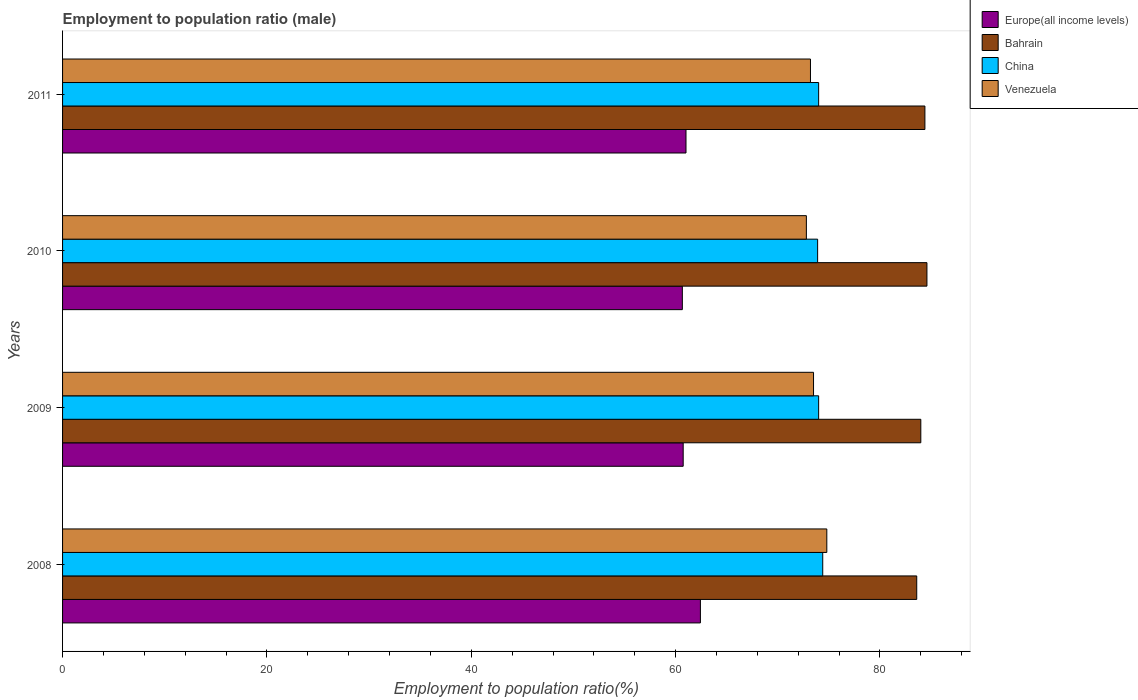Are the number of bars per tick equal to the number of legend labels?
Offer a very short reply. Yes. Are the number of bars on each tick of the Y-axis equal?
Offer a terse response. Yes. How many bars are there on the 4th tick from the top?
Provide a succinct answer. 4. How many bars are there on the 2nd tick from the bottom?
Provide a succinct answer. 4. In how many cases, is the number of bars for a given year not equal to the number of legend labels?
Provide a succinct answer. 0. What is the employment to population ratio in Europe(all income levels) in 2010?
Provide a succinct answer. 60.66. Across all years, what is the maximum employment to population ratio in China?
Provide a succinct answer. 74.4. Across all years, what is the minimum employment to population ratio in Europe(all income levels)?
Keep it short and to the point. 60.66. In which year was the employment to population ratio in Europe(all income levels) minimum?
Offer a terse response. 2010. What is the total employment to population ratio in Europe(all income levels) in the graph?
Your answer should be compact. 244.85. What is the difference between the employment to population ratio in China in 2009 and that in 2010?
Offer a terse response. 0.1. What is the difference between the employment to population ratio in Venezuela in 2010 and the employment to population ratio in Bahrain in 2008?
Give a very brief answer. -10.8. What is the average employment to population ratio in Europe(all income levels) per year?
Ensure brevity in your answer.  61.21. In the year 2010, what is the difference between the employment to population ratio in Venezuela and employment to population ratio in Europe(all income levels)?
Provide a succinct answer. 12.14. In how many years, is the employment to population ratio in Venezuela greater than 20 %?
Make the answer very short. 4. What is the ratio of the employment to population ratio in Venezuela in 2008 to that in 2009?
Offer a very short reply. 1.02. Is the difference between the employment to population ratio in Venezuela in 2008 and 2010 greater than the difference between the employment to population ratio in Europe(all income levels) in 2008 and 2010?
Provide a short and direct response. Yes. What is the difference between the highest and the second highest employment to population ratio in Bahrain?
Give a very brief answer. 0.2. What is the difference between the highest and the lowest employment to population ratio in Bahrain?
Make the answer very short. 1. Is it the case that in every year, the sum of the employment to population ratio in China and employment to population ratio in Venezuela is greater than the sum of employment to population ratio in Europe(all income levels) and employment to population ratio in Bahrain?
Provide a short and direct response. Yes. What does the 1st bar from the top in 2009 represents?
Your response must be concise. Venezuela. What does the 1st bar from the bottom in 2009 represents?
Your response must be concise. Europe(all income levels). How many bars are there?
Keep it short and to the point. 16. What is the difference between two consecutive major ticks on the X-axis?
Keep it short and to the point. 20. Does the graph contain any zero values?
Ensure brevity in your answer.  No. Does the graph contain grids?
Provide a short and direct response. No. How many legend labels are there?
Provide a short and direct response. 4. What is the title of the graph?
Provide a short and direct response. Employment to population ratio (male). Does "Angola" appear as one of the legend labels in the graph?
Your answer should be compact. No. What is the label or title of the X-axis?
Your response must be concise. Employment to population ratio(%). What is the Employment to population ratio(%) of Europe(all income levels) in 2008?
Provide a succinct answer. 62.43. What is the Employment to population ratio(%) in Bahrain in 2008?
Give a very brief answer. 83.6. What is the Employment to population ratio(%) of China in 2008?
Give a very brief answer. 74.4. What is the Employment to population ratio(%) of Venezuela in 2008?
Give a very brief answer. 74.8. What is the Employment to population ratio(%) in Europe(all income levels) in 2009?
Provide a short and direct response. 60.74. What is the Employment to population ratio(%) of Venezuela in 2009?
Your answer should be very brief. 73.5. What is the Employment to population ratio(%) of Europe(all income levels) in 2010?
Provide a succinct answer. 60.66. What is the Employment to population ratio(%) of Bahrain in 2010?
Provide a succinct answer. 84.6. What is the Employment to population ratio(%) in China in 2010?
Provide a short and direct response. 73.9. What is the Employment to population ratio(%) of Venezuela in 2010?
Keep it short and to the point. 72.8. What is the Employment to population ratio(%) in Europe(all income levels) in 2011?
Provide a succinct answer. 61.02. What is the Employment to population ratio(%) of Bahrain in 2011?
Give a very brief answer. 84.4. What is the Employment to population ratio(%) in Venezuela in 2011?
Your response must be concise. 73.2. Across all years, what is the maximum Employment to population ratio(%) of Europe(all income levels)?
Your answer should be compact. 62.43. Across all years, what is the maximum Employment to population ratio(%) in Bahrain?
Ensure brevity in your answer.  84.6. Across all years, what is the maximum Employment to population ratio(%) in China?
Offer a terse response. 74.4. Across all years, what is the maximum Employment to population ratio(%) of Venezuela?
Provide a succinct answer. 74.8. Across all years, what is the minimum Employment to population ratio(%) in Europe(all income levels)?
Provide a short and direct response. 60.66. Across all years, what is the minimum Employment to population ratio(%) of Bahrain?
Your answer should be very brief. 83.6. Across all years, what is the minimum Employment to population ratio(%) of China?
Give a very brief answer. 73.9. Across all years, what is the minimum Employment to population ratio(%) of Venezuela?
Provide a succinct answer. 72.8. What is the total Employment to population ratio(%) of Europe(all income levels) in the graph?
Offer a terse response. 244.85. What is the total Employment to population ratio(%) of Bahrain in the graph?
Ensure brevity in your answer.  336.6. What is the total Employment to population ratio(%) of China in the graph?
Ensure brevity in your answer.  296.3. What is the total Employment to population ratio(%) of Venezuela in the graph?
Offer a terse response. 294.3. What is the difference between the Employment to population ratio(%) of Europe(all income levels) in 2008 and that in 2009?
Ensure brevity in your answer.  1.69. What is the difference between the Employment to population ratio(%) in Bahrain in 2008 and that in 2009?
Provide a succinct answer. -0.4. What is the difference between the Employment to population ratio(%) in Europe(all income levels) in 2008 and that in 2010?
Ensure brevity in your answer.  1.77. What is the difference between the Employment to population ratio(%) in Europe(all income levels) in 2008 and that in 2011?
Give a very brief answer. 1.41. What is the difference between the Employment to population ratio(%) in China in 2008 and that in 2011?
Offer a terse response. 0.4. What is the difference between the Employment to population ratio(%) of Europe(all income levels) in 2009 and that in 2010?
Your answer should be compact. 0.08. What is the difference between the Employment to population ratio(%) of Bahrain in 2009 and that in 2010?
Provide a succinct answer. -0.6. What is the difference between the Employment to population ratio(%) in Venezuela in 2009 and that in 2010?
Keep it short and to the point. 0.7. What is the difference between the Employment to population ratio(%) in Europe(all income levels) in 2009 and that in 2011?
Keep it short and to the point. -0.27. What is the difference between the Employment to population ratio(%) of Bahrain in 2009 and that in 2011?
Give a very brief answer. -0.4. What is the difference between the Employment to population ratio(%) in Venezuela in 2009 and that in 2011?
Provide a short and direct response. 0.3. What is the difference between the Employment to population ratio(%) in Europe(all income levels) in 2010 and that in 2011?
Keep it short and to the point. -0.36. What is the difference between the Employment to population ratio(%) in Bahrain in 2010 and that in 2011?
Your response must be concise. 0.2. What is the difference between the Employment to population ratio(%) in China in 2010 and that in 2011?
Make the answer very short. -0.1. What is the difference between the Employment to population ratio(%) in Europe(all income levels) in 2008 and the Employment to population ratio(%) in Bahrain in 2009?
Your answer should be compact. -21.57. What is the difference between the Employment to population ratio(%) in Europe(all income levels) in 2008 and the Employment to population ratio(%) in China in 2009?
Your response must be concise. -11.57. What is the difference between the Employment to population ratio(%) in Europe(all income levels) in 2008 and the Employment to population ratio(%) in Venezuela in 2009?
Your response must be concise. -11.07. What is the difference between the Employment to population ratio(%) in Bahrain in 2008 and the Employment to population ratio(%) in China in 2009?
Offer a very short reply. 9.6. What is the difference between the Employment to population ratio(%) of Europe(all income levels) in 2008 and the Employment to population ratio(%) of Bahrain in 2010?
Provide a succinct answer. -22.17. What is the difference between the Employment to population ratio(%) of Europe(all income levels) in 2008 and the Employment to population ratio(%) of China in 2010?
Give a very brief answer. -11.47. What is the difference between the Employment to population ratio(%) in Europe(all income levels) in 2008 and the Employment to population ratio(%) in Venezuela in 2010?
Ensure brevity in your answer.  -10.37. What is the difference between the Employment to population ratio(%) of China in 2008 and the Employment to population ratio(%) of Venezuela in 2010?
Your answer should be compact. 1.6. What is the difference between the Employment to population ratio(%) in Europe(all income levels) in 2008 and the Employment to population ratio(%) in Bahrain in 2011?
Provide a short and direct response. -21.97. What is the difference between the Employment to population ratio(%) in Europe(all income levels) in 2008 and the Employment to population ratio(%) in China in 2011?
Give a very brief answer. -11.57. What is the difference between the Employment to population ratio(%) in Europe(all income levels) in 2008 and the Employment to population ratio(%) in Venezuela in 2011?
Your response must be concise. -10.77. What is the difference between the Employment to population ratio(%) of Bahrain in 2008 and the Employment to population ratio(%) of Venezuela in 2011?
Your answer should be compact. 10.4. What is the difference between the Employment to population ratio(%) of China in 2008 and the Employment to population ratio(%) of Venezuela in 2011?
Provide a succinct answer. 1.2. What is the difference between the Employment to population ratio(%) in Europe(all income levels) in 2009 and the Employment to population ratio(%) in Bahrain in 2010?
Provide a succinct answer. -23.86. What is the difference between the Employment to population ratio(%) in Europe(all income levels) in 2009 and the Employment to population ratio(%) in China in 2010?
Offer a very short reply. -13.16. What is the difference between the Employment to population ratio(%) in Europe(all income levels) in 2009 and the Employment to population ratio(%) in Venezuela in 2010?
Give a very brief answer. -12.06. What is the difference between the Employment to population ratio(%) in Bahrain in 2009 and the Employment to population ratio(%) in China in 2010?
Your answer should be very brief. 10.1. What is the difference between the Employment to population ratio(%) of China in 2009 and the Employment to population ratio(%) of Venezuela in 2010?
Provide a succinct answer. 1.2. What is the difference between the Employment to population ratio(%) in Europe(all income levels) in 2009 and the Employment to population ratio(%) in Bahrain in 2011?
Provide a succinct answer. -23.66. What is the difference between the Employment to population ratio(%) of Europe(all income levels) in 2009 and the Employment to population ratio(%) of China in 2011?
Your answer should be very brief. -13.26. What is the difference between the Employment to population ratio(%) in Europe(all income levels) in 2009 and the Employment to population ratio(%) in Venezuela in 2011?
Keep it short and to the point. -12.46. What is the difference between the Employment to population ratio(%) in China in 2009 and the Employment to population ratio(%) in Venezuela in 2011?
Your response must be concise. 0.8. What is the difference between the Employment to population ratio(%) of Europe(all income levels) in 2010 and the Employment to population ratio(%) of Bahrain in 2011?
Your answer should be compact. -23.74. What is the difference between the Employment to population ratio(%) of Europe(all income levels) in 2010 and the Employment to population ratio(%) of China in 2011?
Give a very brief answer. -13.34. What is the difference between the Employment to population ratio(%) of Europe(all income levels) in 2010 and the Employment to population ratio(%) of Venezuela in 2011?
Keep it short and to the point. -12.54. What is the difference between the Employment to population ratio(%) of Bahrain in 2010 and the Employment to population ratio(%) of China in 2011?
Your answer should be very brief. 10.6. What is the difference between the Employment to population ratio(%) in Bahrain in 2010 and the Employment to population ratio(%) in Venezuela in 2011?
Offer a terse response. 11.4. What is the average Employment to population ratio(%) in Europe(all income levels) per year?
Your answer should be compact. 61.21. What is the average Employment to population ratio(%) in Bahrain per year?
Provide a succinct answer. 84.15. What is the average Employment to population ratio(%) in China per year?
Make the answer very short. 74.08. What is the average Employment to population ratio(%) of Venezuela per year?
Ensure brevity in your answer.  73.58. In the year 2008, what is the difference between the Employment to population ratio(%) of Europe(all income levels) and Employment to population ratio(%) of Bahrain?
Keep it short and to the point. -21.17. In the year 2008, what is the difference between the Employment to population ratio(%) in Europe(all income levels) and Employment to population ratio(%) in China?
Keep it short and to the point. -11.97. In the year 2008, what is the difference between the Employment to population ratio(%) in Europe(all income levels) and Employment to population ratio(%) in Venezuela?
Keep it short and to the point. -12.37. In the year 2008, what is the difference between the Employment to population ratio(%) in Bahrain and Employment to population ratio(%) in Venezuela?
Offer a very short reply. 8.8. In the year 2009, what is the difference between the Employment to population ratio(%) in Europe(all income levels) and Employment to population ratio(%) in Bahrain?
Provide a short and direct response. -23.26. In the year 2009, what is the difference between the Employment to population ratio(%) of Europe(all income levels) and Employment to population ratio(%) of China?
Make the answer very short. -13.26. In the year 2009, what is the difference between the Employment to population ratio(%) in Europe(all income levels) and Employment to population ratio(%) in Venezuela?
Offer a terse response. -12.76. In the year 2009, what is the difference between the Employment to population ratio(%) of Bahrain and Employment to population ratio(%) of Venezuela?
Ensure brevity in your answer.  10.5. In the year 2009, what is the difference between the Employment to population ratio(%) in China and Employment to population ratio(%) in Venezuela?
Give a very brief answer. 0.5. In the year 2010, what is the difference between the Employment to population ratio(%) of Europe(all income levels) and Employment to population ratio(%) of Bahrain?
Your answer should be compact. -23.94. In the year 2010, what is the difference between the Employment to population ratio(%) of Europe(all income levels) and Employment to population ratio(%) of China?
Make the answer very short. -13.24. In the year 2010, what is the difference between the Employment to population ratio(%) in Europe(all income levels) and Employment to population ratio(%) in Venezuela?
Your answer should be very brief. -12.14. In the year 2010, what is the difference between the Employment to population ratio(%) of Bahrain and Employment to population ratio(%) of China?
Make the answer very short. 10.7. In the year 2010, what is the difference between the Employment to population ratio(%) of Bahrain and Employment to population ratio(%) of Venezuela?
Keep it short and to the point. 11.8. In the year 2010, what is the difference between the Employment to population ratio(%) in China and Employment to population ratio(%) in Venezuela?
Your answer should be compact. 1.1. In the year 2011, what is the difference between the Employment to population ratio(%) of Europe(all income levels) and Employment to population ratio(%) of Bahrain?
Your answer should be very brief. -23.38. In the year 2011, what is the difference between the Employment to population ratio(%) in Europe(all income levels) and Employment to population ratio(%) in China?
Your answer should be very brief. -12.98. In the year 2011, what is the difference between the Employment to population ratio(%) in Europe(all income levels) and Employment to population ratio(%) in Venezuela?
Your answer should be compact. -12.18. In the year 2011, what is the difference between the Employment to population ratio(%) of Bahrain and Employment to population ratio(%) of China?
Make the answer very short. 10.4. What is the ratio of the Employment to population ratio(%) of Europe(all income levels) in 2008 to that in 2009?
Your answer should be very brief. 1.03. What is the ratio of the Employment to population ratio(%) of China in 2008 to that in 2009?
Offer a terse response. 1.01. What is the ratio of the Employment to population ratio(%) of Venezuela in 2008 to that in 2009?
Provide a short and direct response. 1.02. What is the ratio of the Employment to population ratio(%) in Europe(all income levels) in 2008 to that in 2010?
Ensure brevity in your answer.  1.03. What is the ratio of the Employment to population ratio(%) of Bahrain in 2008 to that in 2010?
Your response must be concise. 0.99. What is the ratio of the Employment to population ratio(%) of China in 2008 to that in 2010?
Offer a terse response. 1.01. What is the ratio of the Employment to population ratio(%) in Venezuela in 2008 to that in 2010?
Keep it short and to the point. 1.03. What is the ratio of the Employment to population ratio(%) in Europe(all income levels) in 2008 to that in 2011?
Ensure brevity in your answer.  1.02. What is the ratio of the Employment to population ratio(%) in China in 2008 to that in 2011?
Make the answer very short. 1.01. What is the ratio of the Employment to population ratio(%) of Venezuela in 2008 to that in 2011?
Your answer should be very brief. 1.02. What is the ratio of the Employment to population ratio(%) in Venezuela in 2009 to that in 2010?
Your response must be concise. 1.01. What is the ratio of the Employment to population ratio(%) of Venezuela in 2009 to that in 2011?
Your response must be concise. 1. What is the ratio of the Employment to population ratio(%) in Venezuela in 2010 to that in 2011?
Give a very brief answer. 0.99. What is the difference between the highest and the second highest Employment to population ratio(%) in Europe(all income levels)?
Keep it short and to the point. 1.41. What is the difference between the highest and the second highest Employment to population ratio(%) of China?
Ensure brevity in your answer.  0.4. What is the difference between the highest and the second highest Employment to population ratio(%) of Venezuela?
Your answer should be compact. 1.3. What is the difference between the highest and the lowest Employment to population ratio(%) of Europe(all income levels)?
Keep it short and to the point. 1.77. What is the difference between the highest and the lowest Employment to population ratio(%) in Bahrain?
Your response must be concise. 1. What is the difference between the highest and the lowest Employment to population ratio(%) of Venezuela?
Offer a terse response. 2. 